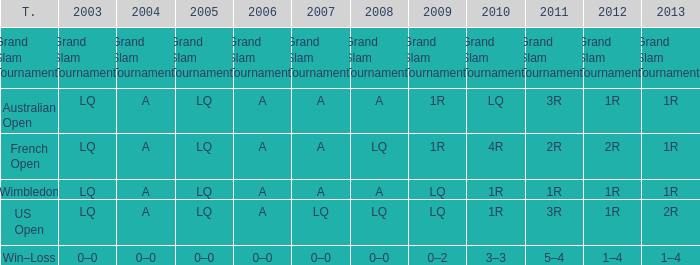Which tournament has a 2013 of 1r, and a 2012 of 1r? Australian Open, Wimbledon. 